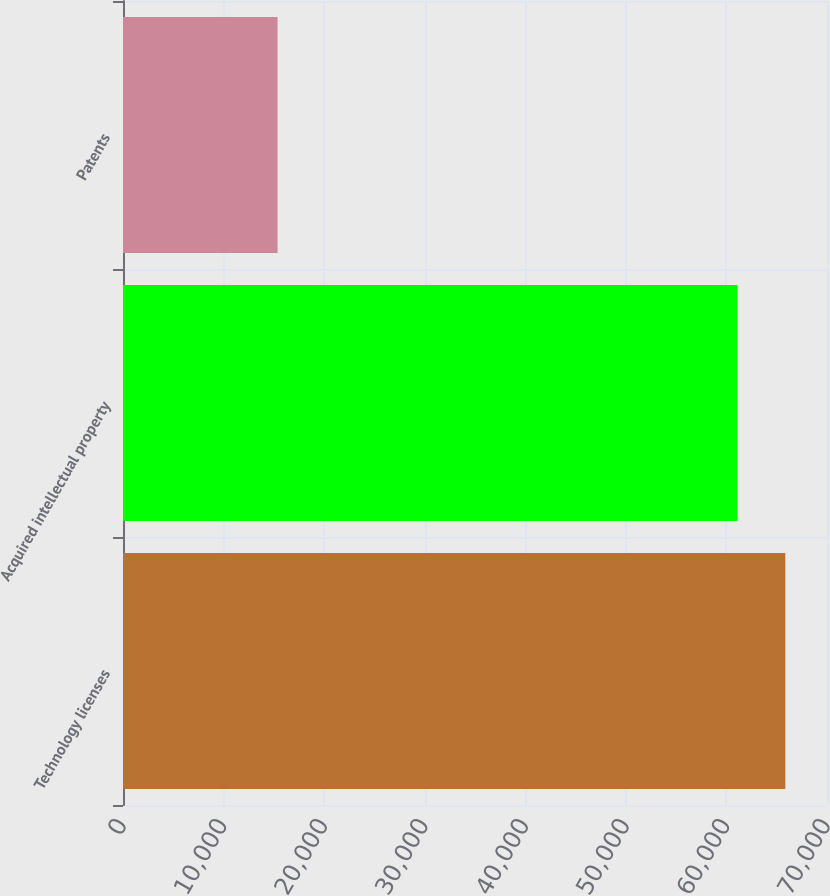<chart> <loc_0><loc_0><loc_500><loc_500><bar_chart><fcel>Technology licenses<fcel>Acquired intellectual property<fcel>Patents<nl><fcel>65856.2<fcel>61114<fcel>15369<nl></chart> 